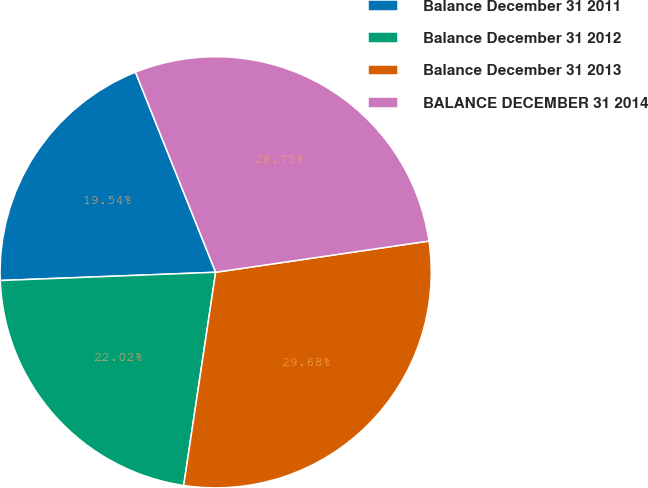<chart> <loc_0><loc_0><loc_500><loc_500><pie_chart><fcel>Balance December 31 2011<fcel>Balance December 31 2012<fcel>Balance December 31 2013<fcel>BALANCE DECEMBER 31 2014<nl><fcel>19.54%<fcel>22.02%<fcel>29.68%<fcel>28.75%<nl></chart> 